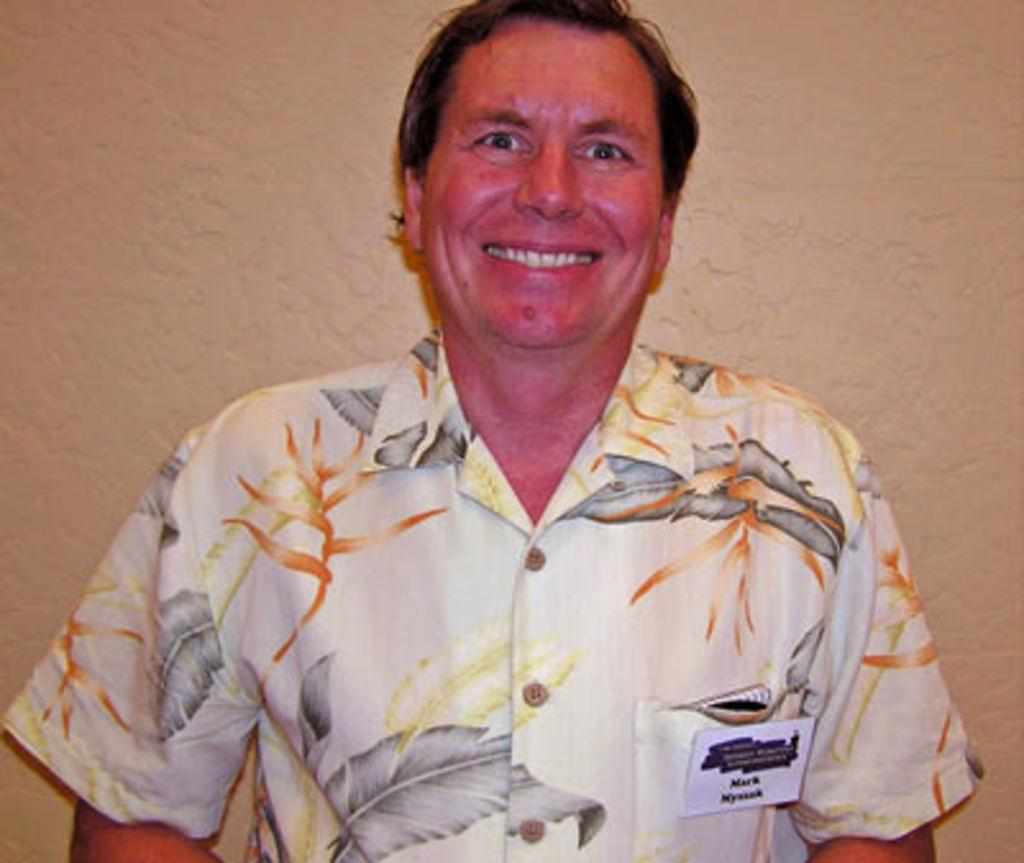Who or what is present in the image? There is a person in the image. What is the person's facial expression? The person has a smile on their face. What can be seen in the background of the image? There is a wall in the background of the image. How much money is the person holding in the image? There is no indication of money in the image; the person is simply smiling. 